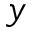Convert formula to latex. <formula><loc_0><loc_0><loc_500><loc_500>y</formula> 